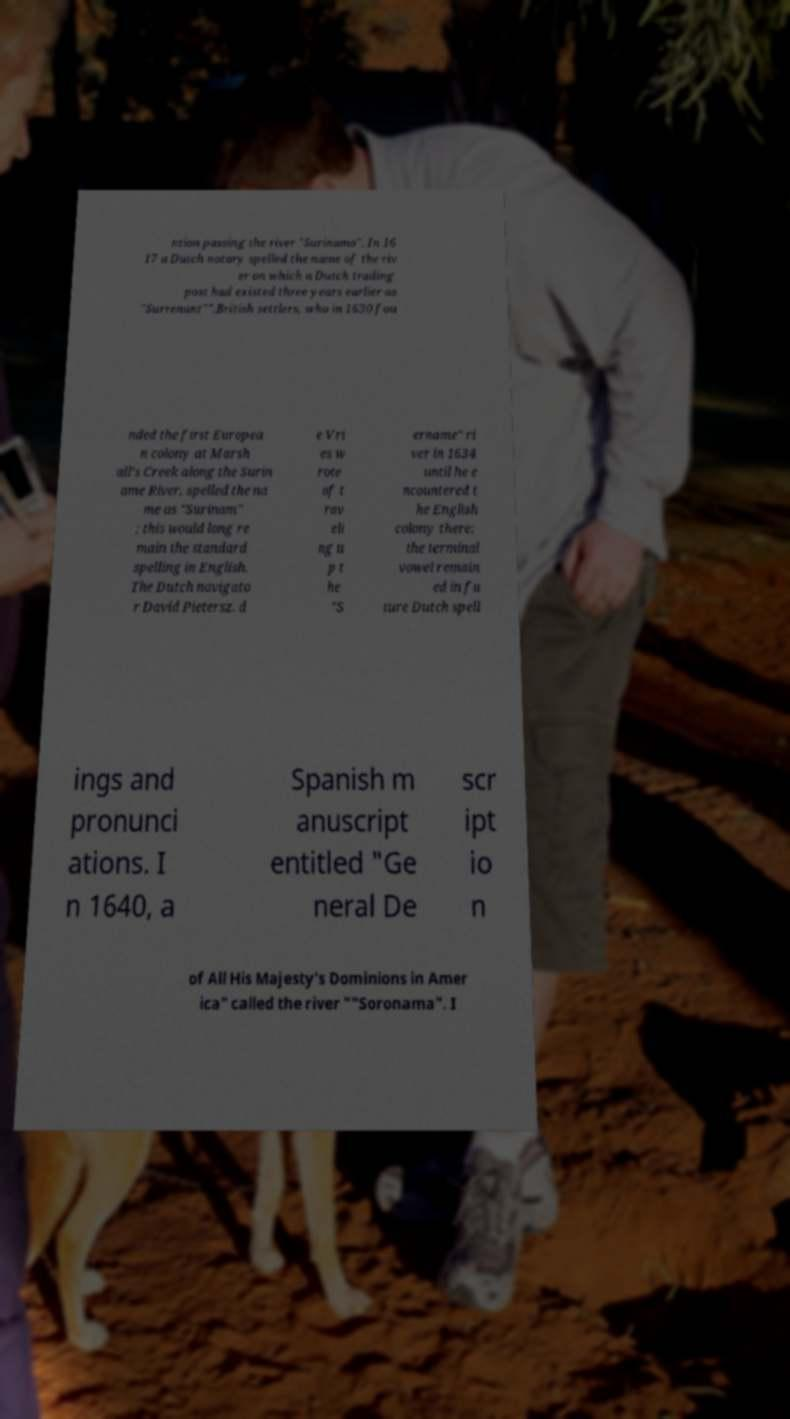Could you extract and type out the text from this image? ntion passing the river "Surinamo". In 16 17 a Dutch notary spelled the name of the riv er on which a Dutch trading post had existed three years earlier as "Surrenant"".British settlers, who in 1630 fou nded the first Europea n colony at Marsh all's Creek along the Surin ame River, spelled the na me as "Surinam" ; this would long re main the standard spelling in English. The Dutch navigato r David Pietersz. d e Vri es w rote of t rav eli ng u p t he "S ername" ri ver in 1634 until he e ncountered t he English colony there; the terminal vowel remain ed in fu ture Dutch spell ings and pronunci ations. I n 1640, a Spanish m anuscript entitled "Ge neral De scr ipt io n of All His Majesty's Dominions in Amer ica" called the river ""Soronama". I 